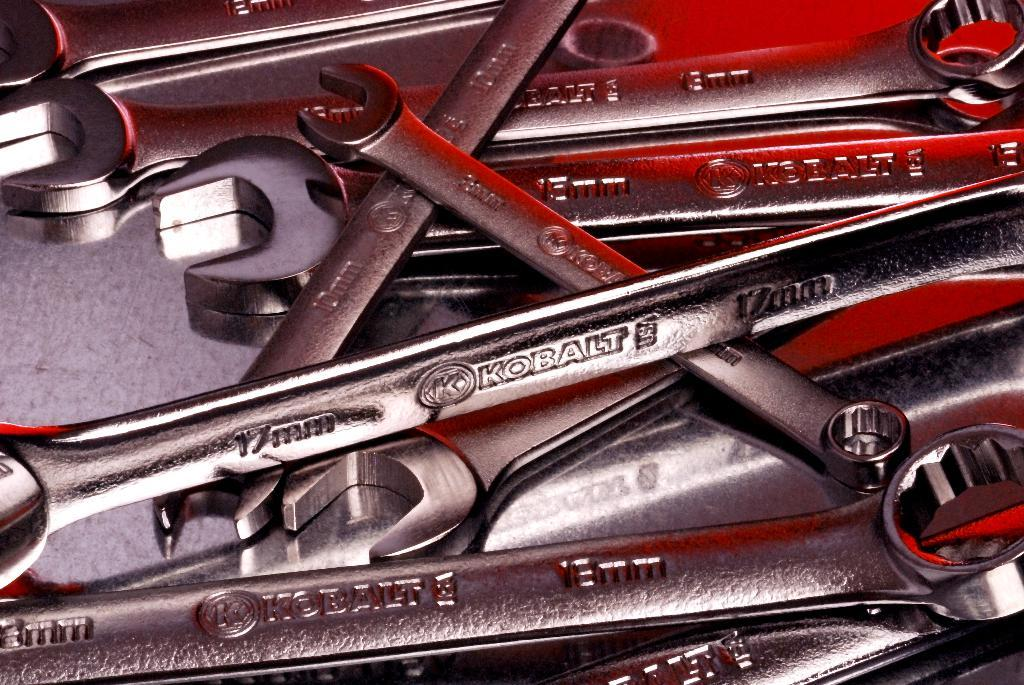What type of tools are visible in the image? There are nut wrenches in the image. Where are the nut wrenches located? The nut wrenches are placed on a surface. How many pears are on the nut wrenches in the image? There are no pears present in the image; it only features nut wrenches. What type of room is shown in the image? The image does not show a room; it only features nut wrenches placed on a surface. 